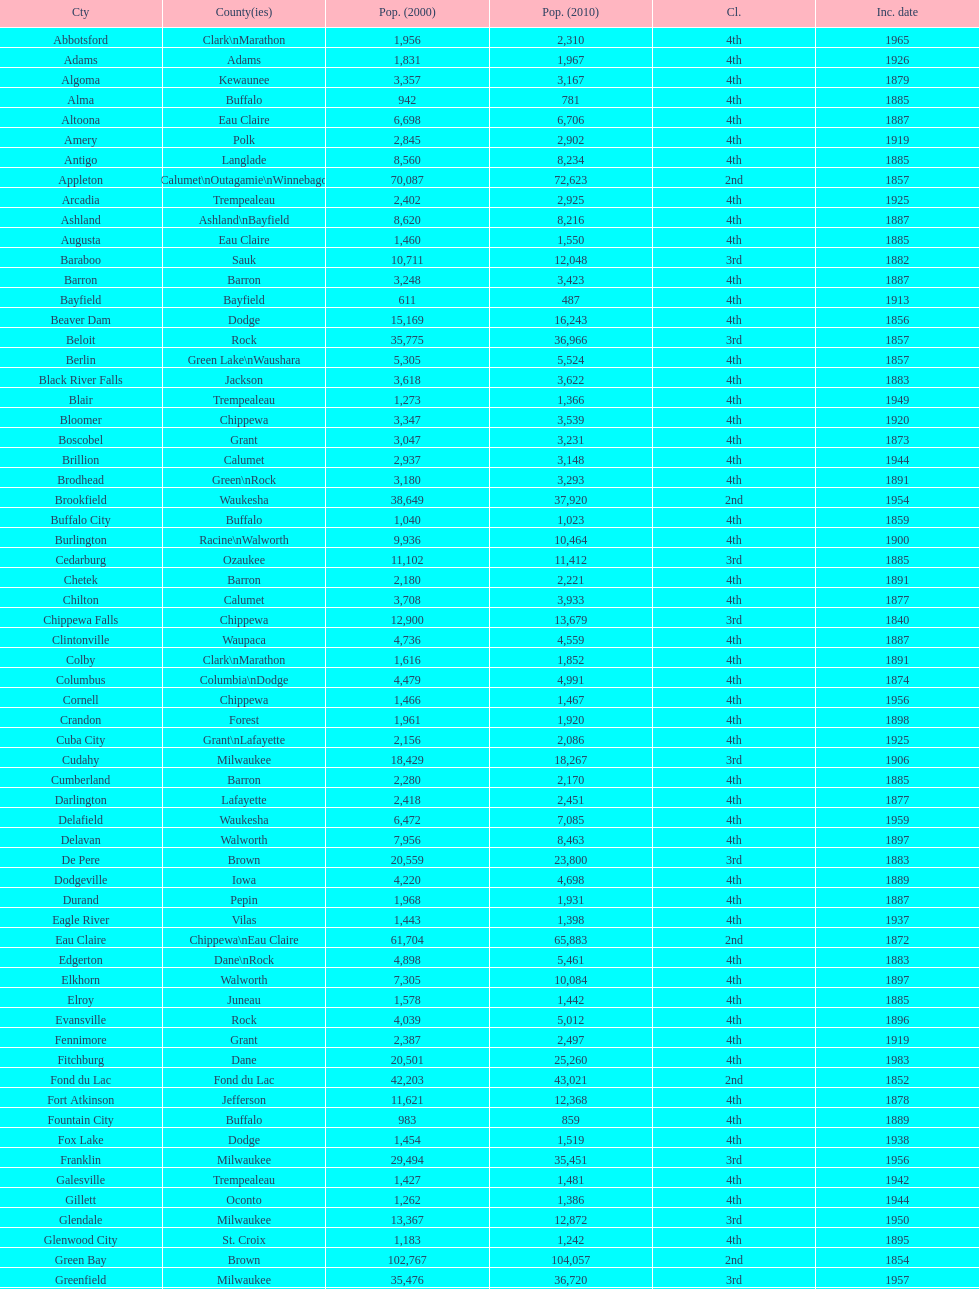Which city has the most population in the 2010 census? Milwaukee. 